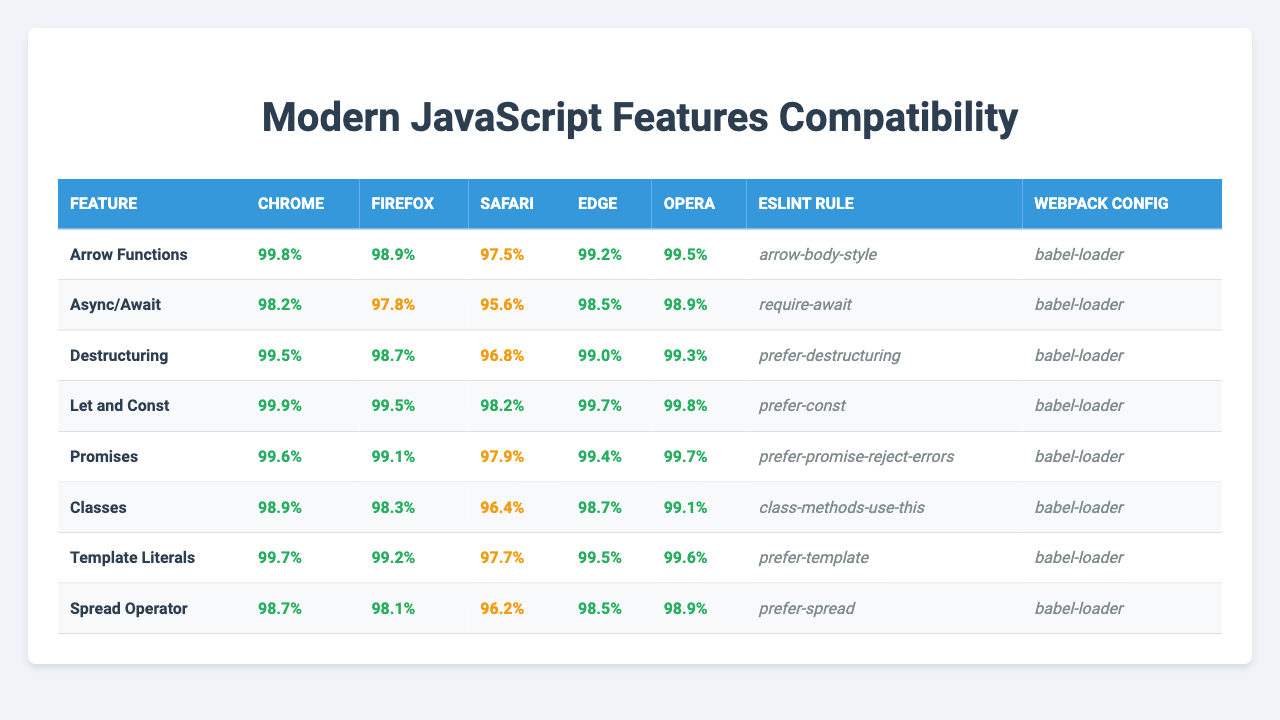What is the compatibility percentage of Arrow Functions in Safari? The compatibility percentage of Arrow Functions in Safari is 97.5%, as shown in the table under the Safari column for the Arrow Functions feature.
Answer: 97.5% Which browser has the highest compatibility for Promises? The browser with the highest compatibility for Promises is Chrome at 99.6%. This can be found by comparing the values in the Promises row across all browser columns.
Answer: Chrome What is the average compatibility percentage for Destructuring across all browsers? The compatibility percentages for Destructuring are: 99.5 (Chrome), 98.7 (Firefox), 96.8 (Safari), 99.0 (Edge), and 99.3 (Opera). Summing these values gives 493.3, and dividing by 5 gives an average of 98.66.
Answer: 98.66 Which feature has the lowest compatibility percentage in Safari? In Safari, the feature with the lowest compatibility percentage is Classes, with a value of 96.4%. By inspecting the Classes row specifically in the Safari column, we can identify this minimum value.
Answer: Classes Are Arrow Functions fully supported (100%) in any of the listed browsers? No, none of the listed browsers show full (100%) support for Arrow Functions, with the highest being 99.8% in Chrome. The percentages in the table confirm that all values are below 100%.
Answer: No How does the compatibility of Async/Await in Firefox compare to that in Chrome? The compatibility of Async/Await in Firefox is 97.8%, whereas in Chrome it's 98.2%. Comparing these two values shows that Chrome has better compatibility than Firefox by a margin of 0.4%.
Answer: Chrome has better compatibility Is there any feature where Opera has lower compatibility than Edge? Yes, in the case of the Spread Operator, Opera has 98.9% compatibility while Edge has 98.5%. By looking at these specific values in the respective rows, it's clear that Opera is higher for this feature.
Answer: Yes, Spread Operator What is the ESLint rule associated with Template Literals? The ESLint rule associated with Template Literals is "prefer-template," which can be found in the ESLint Rule column next to the Template Literals feature.
Answer: prefer-template Which feature has the same compatibility percentage in both Chrome and Opera? The feature with the same compatibility percentage in both Chrome and Opera is Let and Const, with a percentage of 99.9% in Chrome and 99.8% in Opera. By comparing these features in their respective rows, this fact can be confirmed.
Answer: Let and Const What is the difference in compatibility percentage for Classes between Chrome and Safari? The compatibility percentage for Classes in Chrome is 98.9%, and in Safari, it is 96.4%. The difference is 98.9 - 96.4 = 2.5%. This calculation shows how much more compatible the feature is in Chrome compared to Safari.
Answer: 2.5% Which JavaScript feature has the highest overall compatibility across all provided browsers? Let and Const has the highest overall compatibility with 99.9% in Chrome, 99.5% in Firefox, 98.2% in Safari, 99.7% in Edge, and 99.8% in Opera. Checking through all features and respective browser compatibilities confirms this highest value.
Answer: Let and Const 